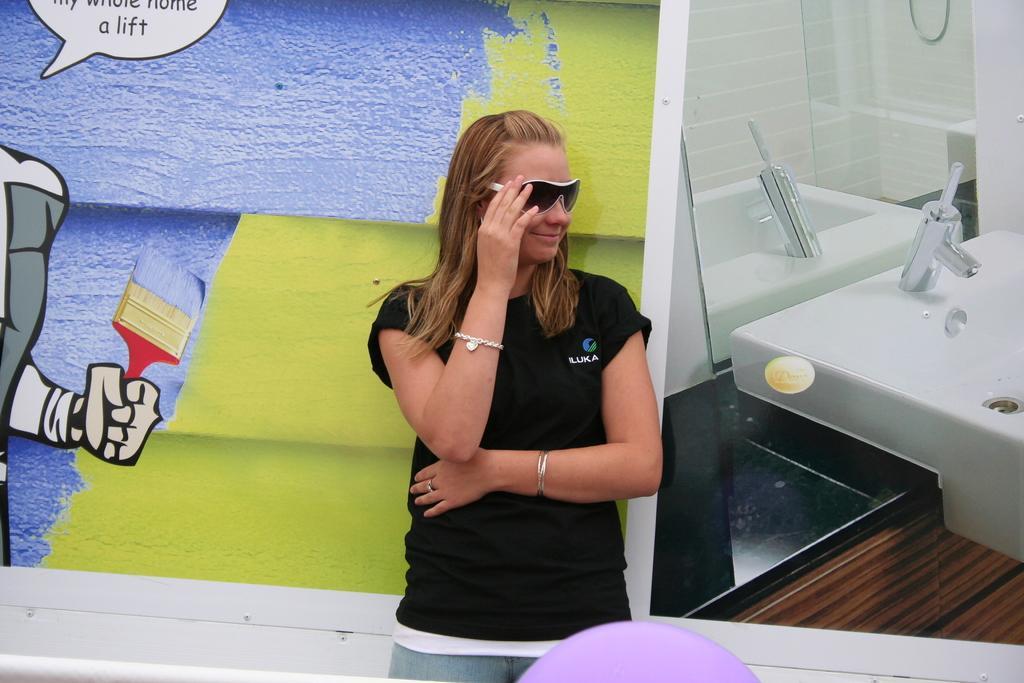Describe this image in one or two sentences. Here I can see a woman wearing black color t-shirt and standing. She is smiling by looking at the right side. At the bottom there is an object which seems to be a balloon. At the back of her there is a wall on which I can see few paintings of a person who is holding brush. In the top left there is some text. On the right side it seems to be an image. Here I can see table sink on which there is a tap, behind there is a mirror. 